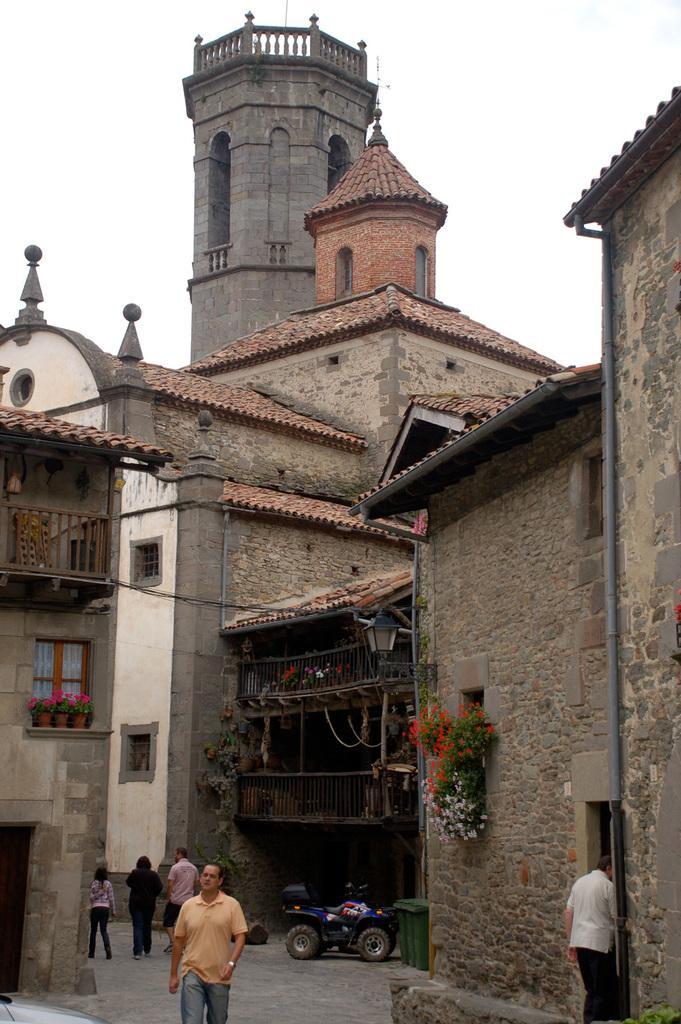Please provide a concise description of this image. There are some persons at the bottom of this image and there is a bike as we can see in the middle of this image, and there is a building in the background. There is a sky at the top of this image. 